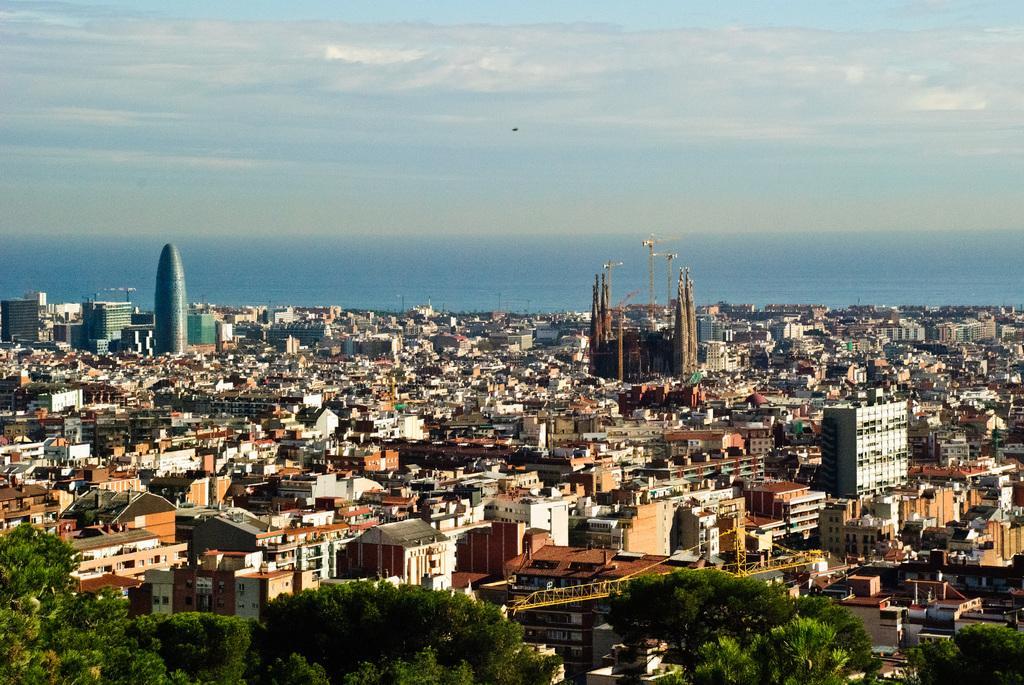Please provide a concise description of this image. In this picture I can see buildings and trees and I can see a crane and I can see a blue cloudy sky. 